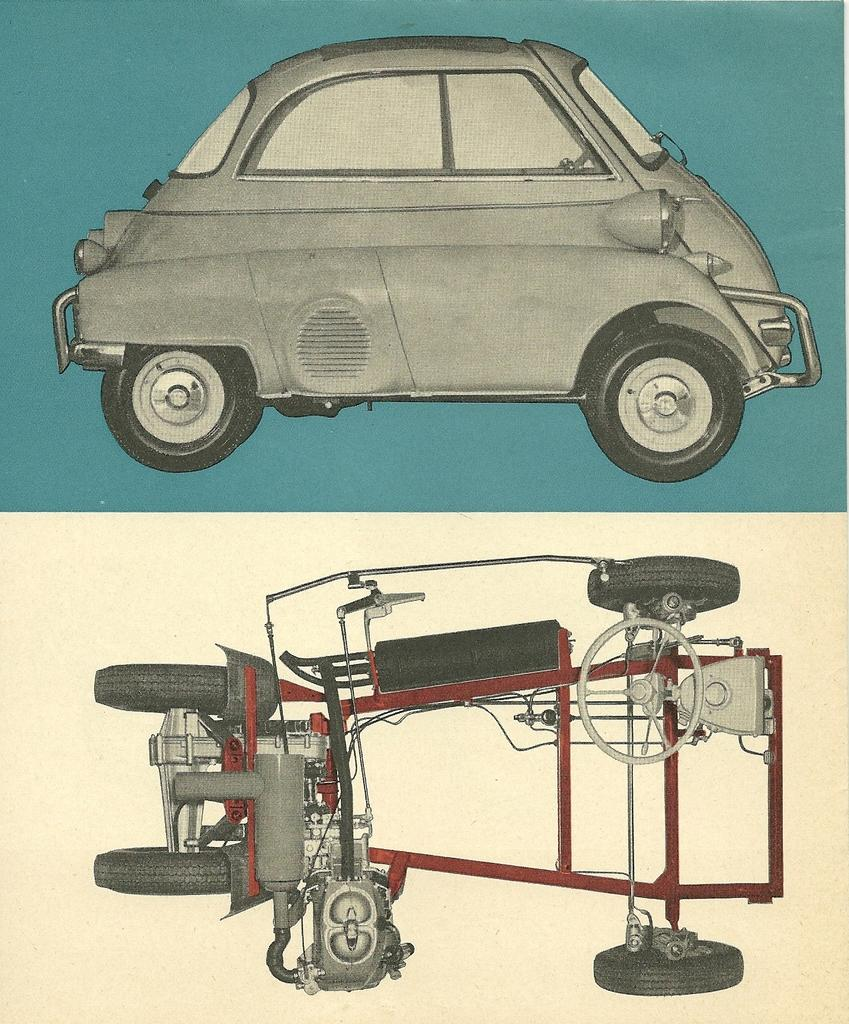What type of artwork is the image? The image is a collage. What is depicted at the top of the collage? There is a vehicle depicted at the top of the collage. What is depicted at the bottom of the collage? There are parts of a vehicle depicted at the bottom of the collage. What type of screw can be seen holding the sea together in the image? There is no screw or sea present in the image; it is a collage featuring a vehicle and its parts. 